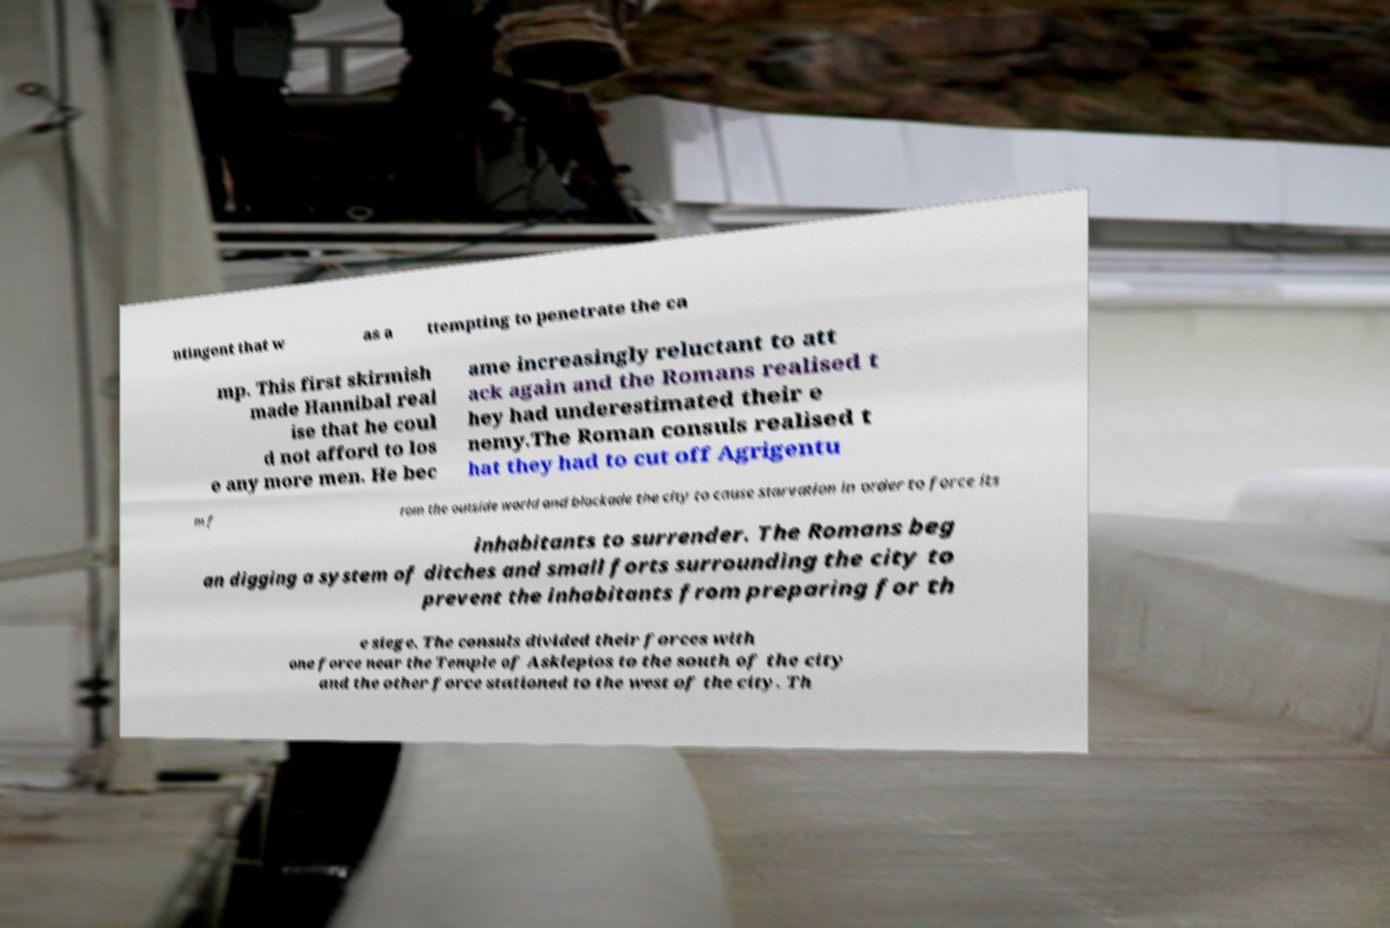I need the written content from this picture converted into text. Can you do that? ntingent that w as a ttempting to penetrate the ca mp. This first skirmish made Hannibal real ise that he coul d not afford to los e any more men. He bec ame increasingly reluctant to att ack again and the Romans realised t hey had underestimated their e nemy.The Roman consuls realised t hat they had to cut off Agrigentu m f rom the outside world and blockade the city to cause starvation in order to force its inhabitants to surrender. The Romans beg an digging a system of ditches and small forts surrounding the city to prevent the inhabitants from preparing for th e siege. The consuls divided their forces with one force near the Temple of Asklepios to the south of the city and the other force stationed to the west of the city. Th 